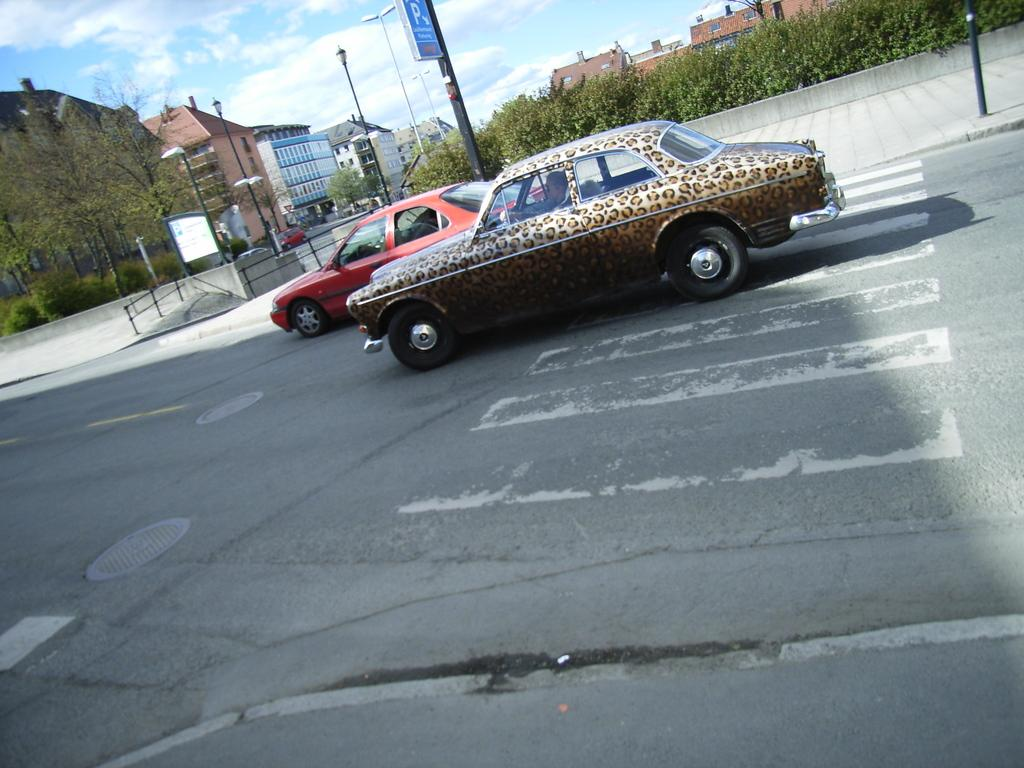What can be seen on the road in the image? There are cars on the road in the image. What is visible in the background of the image? There are buildings and trees in the background of the image. What is visible at the top of the image? The sky is visible at the top of the image. How does the sky appear in the image? The sky appears to be cloudy in the image. Where is the drain located in the image? There is no drain present in the image. How many kittens can be seen playing in the trees in the background? There are no kittens present in the image. 